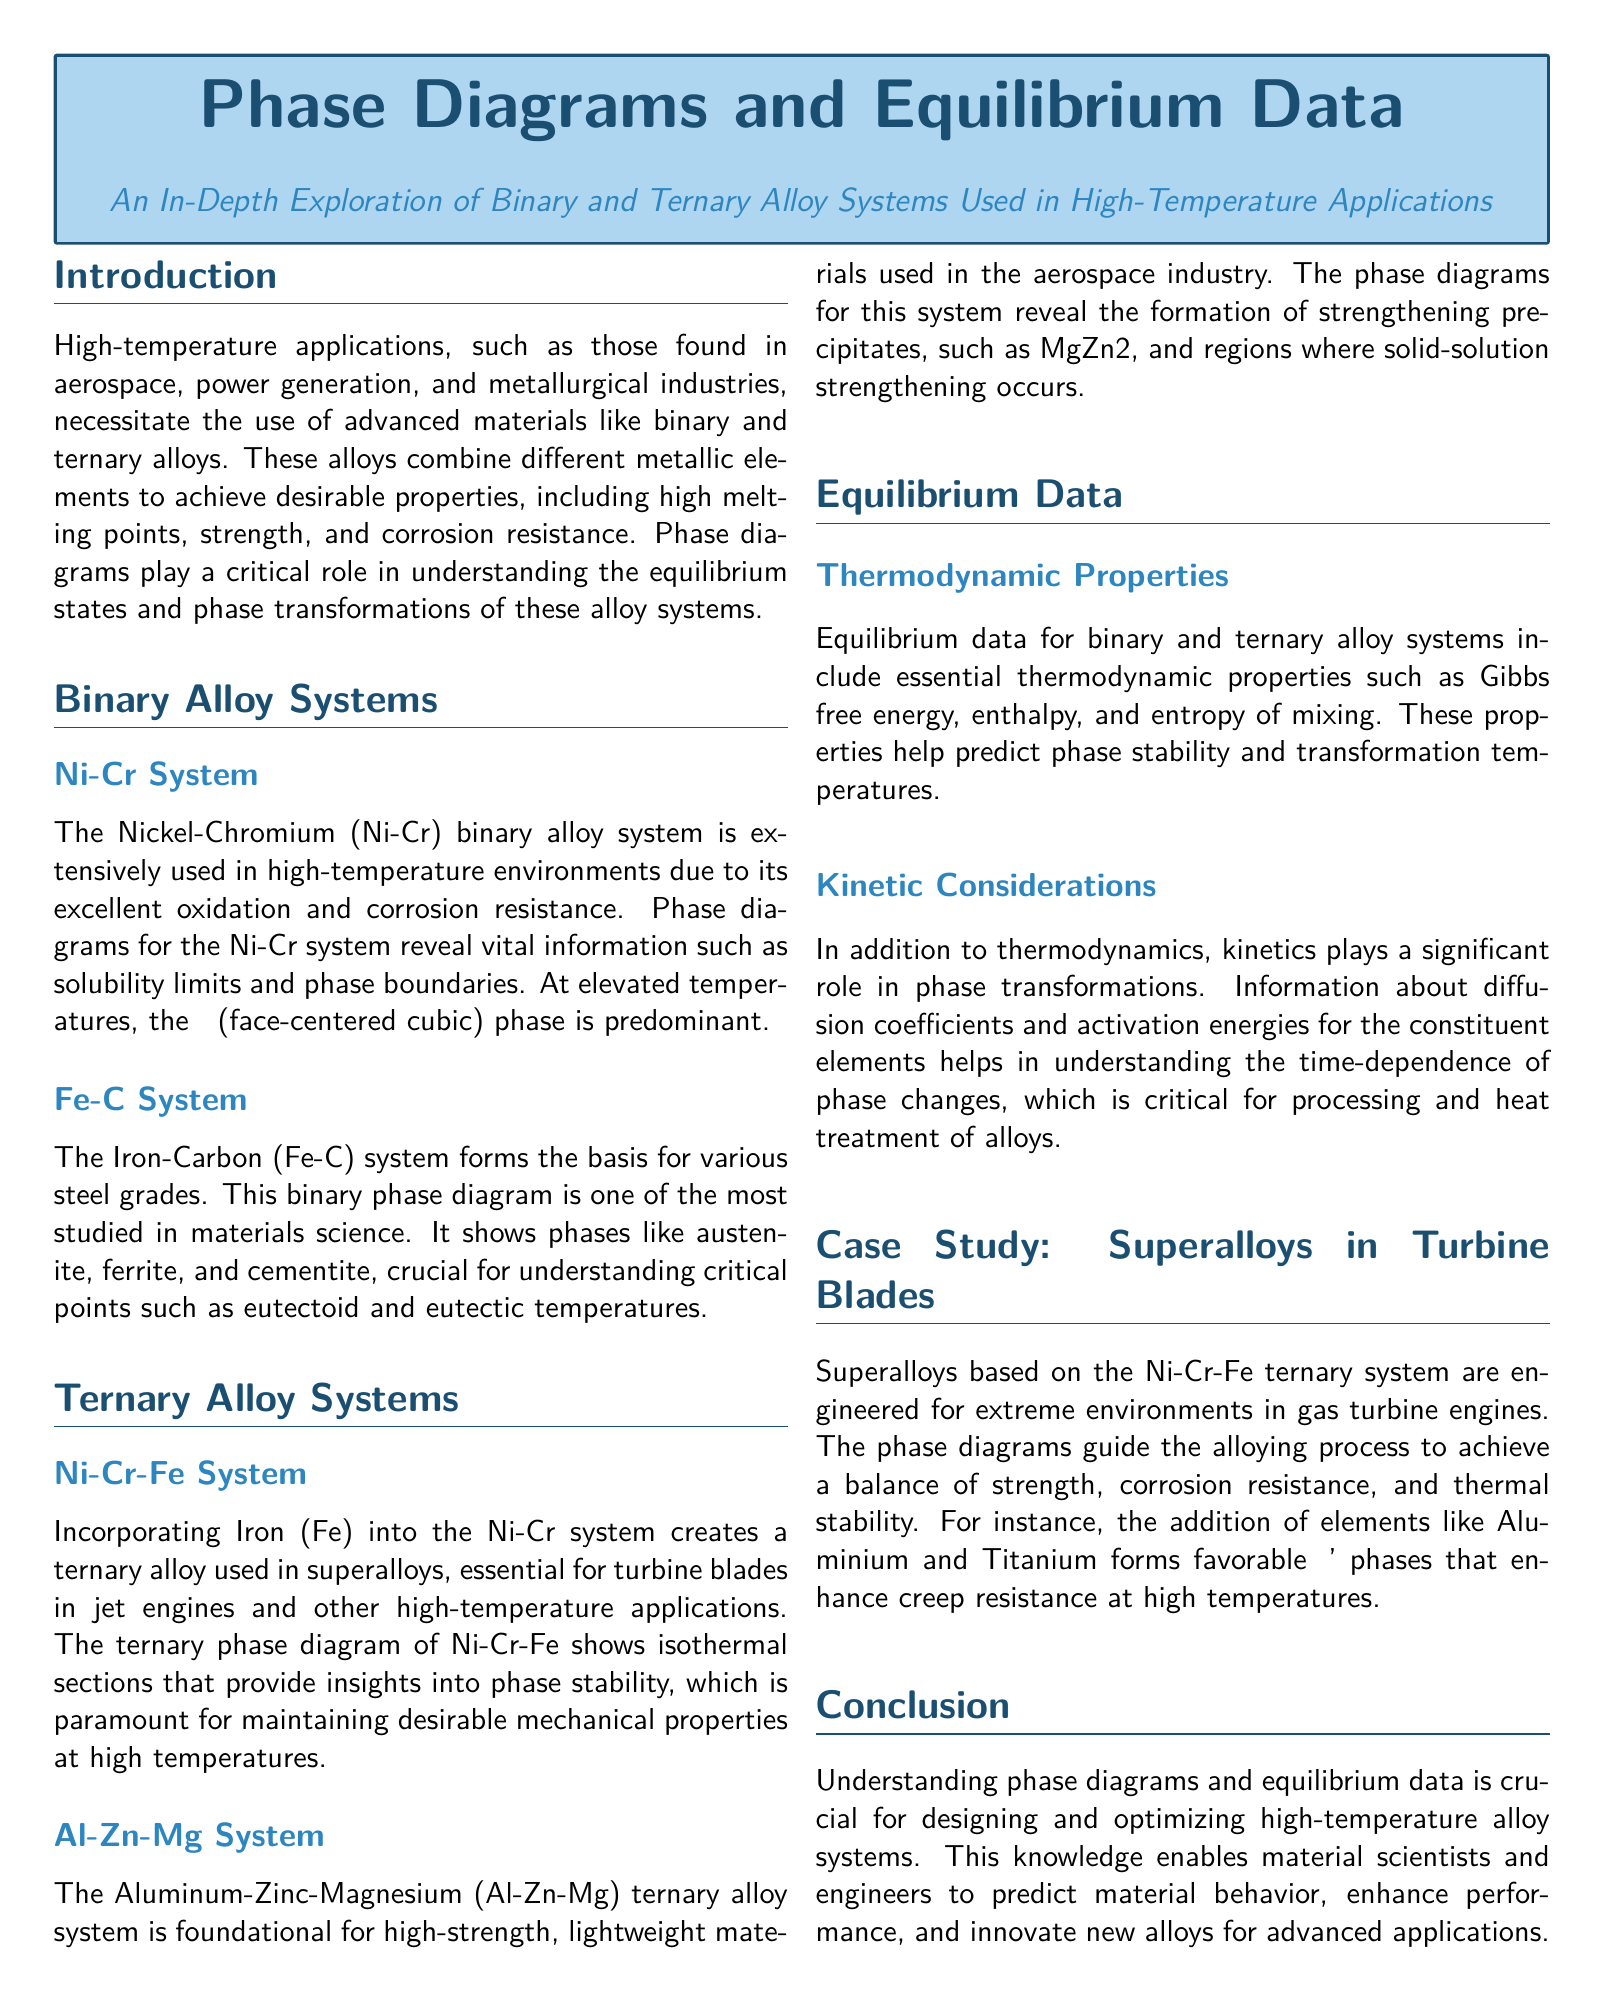What is the primary application of high-temperature alloys? The document states that high-temperature applications include aerospace, power generation, and metallurgical industries.
Answer: Aerospace, power generation, metallurgical industries What is the predominant phase in the Ni-Cr system at elevated temperatures? The document mentions that the γ (face-centered cubic) phase is predominant at elevated temperatures in the Ni-Cr system.
Answer: γ (face-centered cubic) What phases are crucial in the Fe-C system? The document lists phases such as austenite, ferrite, and cementite as crucial for the Fe-C system.
Answer: Austenite, ferrite, cementite What additional element is included in the Ni-Cr-Fe ternary alloy system? The document specifies that Iron (Fe) is incorporated into the Ni-Cr system to create the ternary alloy.
Answer: Iron (Fe) Which strengthening precipitate forms in the Al-Zn-Mg system? The document names MgZn2 as a strengthening precipitate formed in the Al-Zn-Mg system.
Answer: MgZn2 What thermodynamic properties are included in equilibrium data? The document highlights essential thermodynamic properties such as Gibbs free energy, enthalpy, and entropy of mixing.
Answer: Gibbs free energy, enthalpy, entropy of mixing What is a key consideration for phase transformations in the document? The document notes that kinetics plays a significant role, particularly concerning diffusion coefficients and activation energies.
Answer: Kinetics What are superalloys engineered for? According to the document, superalloys are engineered for extreme environments in gas turbine engines.
Answer: Extreme environments in gas turbine engines What phases are enhanced by the addition of Aluminium and Titanium? The document states that the addition of Aluminium and Titanium forms favorable γ' phases.
Answer: γ' phases 